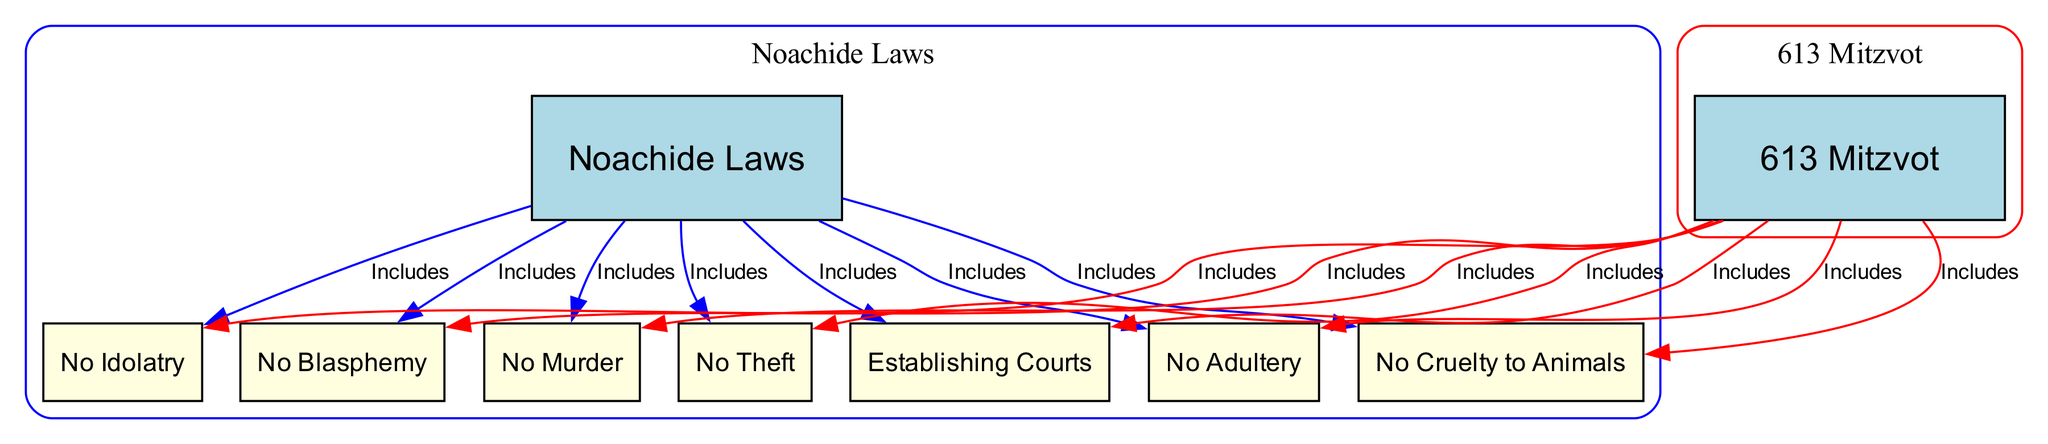What are the Noachide Laws? The Noachide Laws are described in the diagram as "Seven universal laws given to Noah for all humanity." This is directly represented by the label under the corresponding node labeled "Noachide Laws."
Answer: Seven universal laws How many nodes are in the diagram? By counting each unique entity represented in the diagram, it includes two main nodes ("Noachide Laws" and "613 Mitzvot") and seven specific laws branching from each. Thus, the total number of nodes is calculated to be nine.
Answer: Nine What law prohibits murder? The specific law that prohibits murder is labeled as "No Murder" in the diagram. It is clearly indicated under the Noachide Laws, which corresponds to the description provided for that node.
Answer: No Murder How many edges are associated with the 613 Mitzvot? The edges associated with the "613 Mitzvot" node represent connections to the specific laws detailed in the diagram. There are a total of seven distinct edges connecting the 613 Mitzvot to each of the corresponding laws listed.
Answer: Seven Does the Noachide Laws include the prohibition of theft? The diagram shows that the relationships between the Noachide Laws and their specific prohibitions include "No Theft." This relationship illustrates that theft is indeed one of the laws outlined within the Noachide framework.
Answer: Yes Which law addresses cruelty to animals? The law that addresses cruelty to animals is labeled "No Cruelty to Animals" in the diagram. This law is included as one of the Noachide Laws for prohibitions against animal cruelty.
Answer: No Cruelty to Animals What is the relationship between Noachide Laws and establishing courts? The relationship is indicated by an edge in the diagram showing that establishing courts, or "Civil Justice," is included within the Noachide Laws. This signifies that the establishment of legal systems is a requirement under these laws.
Answer: Includes Which category includes the prohibition against adultery? Both the "Noachide Laws" and the "613 Mitzvot" include the prohibition against adultery, as per the edges originating from both the Noachide Laws and the 613 Mitzvot nodes, indicating that this prohibition is recognized in both frameworks.
Answer: Both categories 